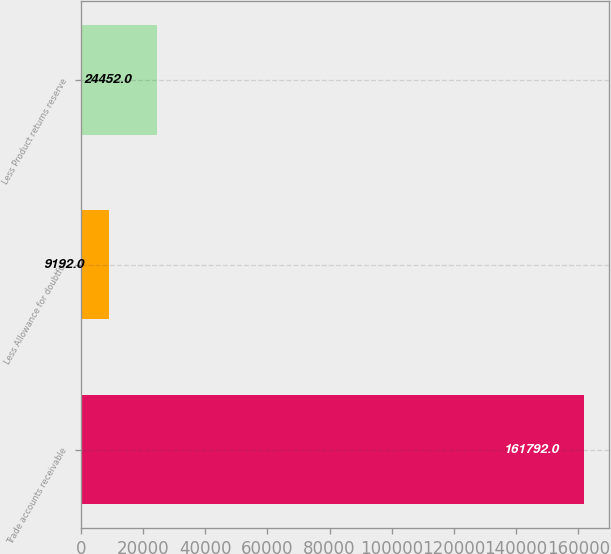Convert chart to OTSL. <chart><loc_0><loc_0><loc_500><loc_500><bar_chart><fcel>Trade accounts receivable<fcel>Less Allowance for doubtful<fcel>Less Product returns reserve<nl><fcel>161792<fcel>9192<fcel>24452<nl></chart> 